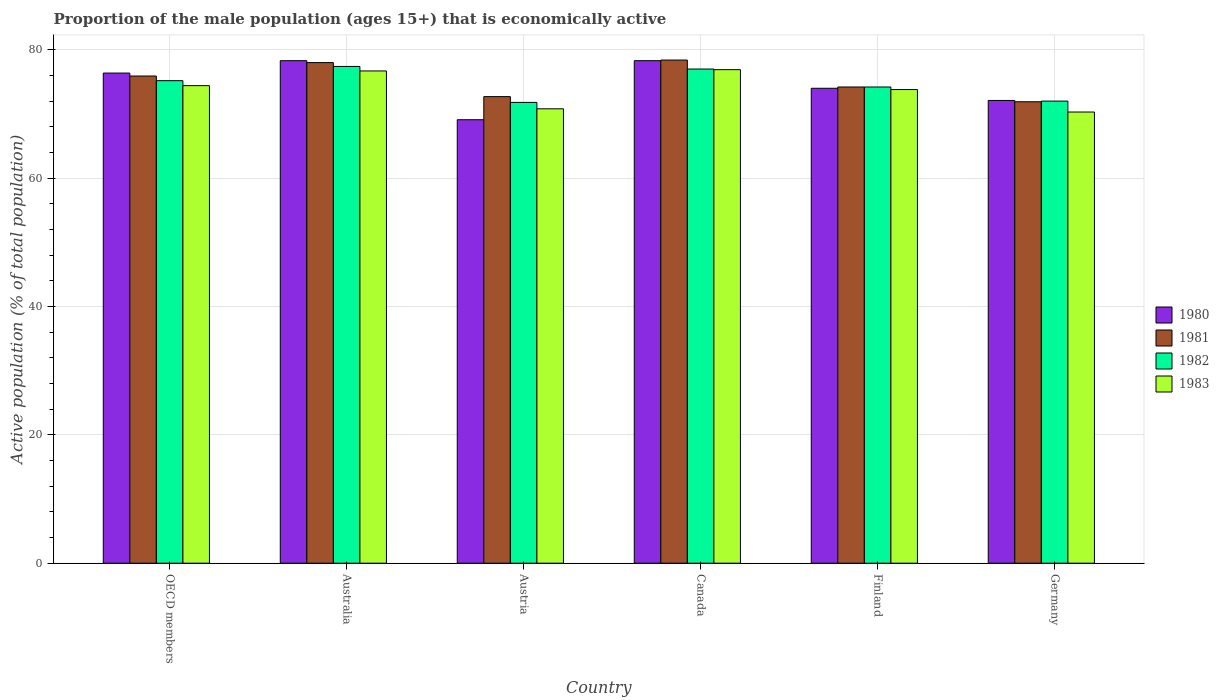How many groups of bars are there?
Ensure brevity in your answer.  6. Are the number of bars per tick equal to the number of legend labels?
Your answer should be very brief. Yes. Are the number of bars on each tick of the X-axis equal?
Your response must be concise. Yes. What is the proportion of the male population that is economically active in 1981 in Canada?
Keep it short and to the point. 78.4. Across all countries, what is the maximum proportion of the male population that is economically active in 1983?
Offer a terse response. 76.9. Across all countries, what is the minimum proportion of the male population that is economically active in 1980?
Your answer should be compact. 69.1. What is the total proportion of the male population that is economically active in 1982 in the graph?
Offer a terse response. 447.58. What is the difference between the proportion of the male population that is economically active in 1982 in Austria and that in Finland?
Offer a very short reply. -2.4. What is the difference between the proportion of the male population that is economically active in 1982 in Canada and the proportion of the male population that is economically active in 1983 in Germany?
Offer a terse response. 6.7. What is the average proportion of the male population that is economically active in 1981 per country?
Your answer should be compact. 75.18. What is the difference between the proportion of the male population that is economically active of/in 1980 and proportion of the male population that is economically active of/in 1982 in Australia?
Provide a short and direct response. 0.9. What is the ratio of the proportion of the male population that is economically active in 1983 in Austria to that in Finland?
Offer a very short reply. 0.96. Is the proportion of the male population that is economically active in 1980 in Austria less than that in OECD members?
Your answer should be very brief. Yes. What is the difference between the highest and the second highest proportion of the male population that is economically active in 1980?
Offer a very short reply. -1.93. What is the difference between the highest and the lowest proportion of the male population that is economically active in 1982?
Your answer should be compact. 5.6. In how many countries, is the proportion of the male population that is economically active in 1980 greater than the average proportion of the male population that is economically active in 1980 taken over all countries?
Offer a very short reply. 3. Is the sum of the proportion of the male population that is economically active in 1982 in Austria and Germany greater than the maximum proportion of the male population that is economically active in 1981 across all countries?
Ensure brevity in your answer.  Yes. Is it the case that in every country, the sum of the proportion of the male population that is economically active in 1981 and proportion of the male population that is economically active in 1982 is greater than the sum of proportion of the male population that is economically active in 1983 and proportion of the male population that is economically active in 1980?
Ensure brevity in your answer.  No. How many countries are there in the graph?
Give a very brief answer. 6. Are the values on the major ticks of Y-axis written in scientific E-notation?
Offer a very short reply. No. How many legend labels are there?
Your answer should be compact. 4. What is the title of the graph?
Ensure brevity in your answer.  Proportion of the male population (ages 15+) that is economically active. Does "2003" appear as one of the legend labels in the graph?
Your answer should be compact. No. What is the label or title of the Y-axis?
Offer a very short reply. Active population (% of total population). What is the Active population (% of total population) in 1980 in OECD members?
Give a very brief answer. 76.37. What is the Active population (% of total population) of 1981 in OECD members?
Keep it short and to the point. 75.91. What is the Active population (% of total population) in 1982 in OECD members?
Your response must be concise. 75.18. What is the Active population (% of total population) of 1983 in OECD members?
Offer a terse response. 74.41. What is the Active population (% of total population) in 1980 in Australia?
Ensure brevity in your answer.  78.3. What is the Active population (% of total population) in 1982 in Australia?
Provide a succinct answer. 77.4. What is the Active population (% of total population) in 1983 in Australia?
Your answer should be very brief. 76.7. What is the Active population (% of total population) in 1980 in Austria?
Make the answer very short. 69.1. What is the Active population (% of total population) in 1981 in Austria?
Make the answer very short. 72.7. What is the Active population (% of total population) in 1982 in Austria?
Ensure brevity in your answer.  71.8. What is the Active population (% of total population) of 1983 in Austria?
Your response must be concise. 70.8. What is the Active population (% of total population) in 1980 in Canada?
Keep it short and to the point. 78.3. What is the Active population (% of total population) in 1981 in Canada?
Provide a succinct answer. 78.4. What is the Active population (% of total population) in 1983 in Canada?
Your answer should be very brief. 76.9. What is the Active population (% of total population) in 1980 in Finland?
Ensure brevity in your answer.  74. What is the Active population (% of total population) in 1981 in Finland?
Your answer should be very brief. 74.2. What is the Active population (% of total population) of 1982 in Finland?
Offer a terse response. 74.2. What is the Active population (% of total population) of 1983 in Finland?
Ensure brevity in your answer.  73.8. What is the Active population (% of total population) in 1980 in Germany?
Keep it short and to the point. 72.1. What is the Active population (% of total population) in 1981 in Germany?
Give a very brief answer. 71.9. What is the Active population (% of total population) in 1983 in Germany?
Keep it short and to the point. 70.3. Across all countries, what is the maximum Active population (% of total population) of 1980?
Ensure brevity in your answer.  78.3. Across all countries, what is the maximum Active population (% of total population) in 1981?
Keep it short and to the point. 78.4. Across all countries, what is the maximum Active population (% of total population) in 1982?
Give a very brief answer. 77.4. Across all countries, what is the maximum Active population (% of total population) in 1983?
Offer a very short reply. 76.9. Across all countries, what is the minimum Active population (% of total population) of 1980?
Provide a succinct answer. 69.1. Across all countries, what is the minimum Active population (% of total population) in 1981?
Ensure brevity in your answer.  71.9. Across all countries, what is the minimum Active population (% of total population) in 1982?
Provide a succinct answer. 71.8. Across all countries, what is the minimum Active population (% of total population) in 1983?
Give a very brief answer. 70.3. What is the total Active population (% of total population) of 1980 in the graph?
Keep it short and to the point. 448.17. What is the total Active population (% of total population) of 1981 in the graph?
Offer a very short reply. 451.11. What is the total Active population (% of total population) of 1982 in the graph?
Ensure brevity in your answer.  447.58. What is the total Active population (% of total population) of 1983 in the graph?
Make the answer very short. 442.91. What is the difference between the Active population (% of total population) of 1980 in OECD members and that in Australia?
Offer a very short reply. -1.93. What is the difference between the Active population (% of total population) of 1981 in OECD members and that in Australia?
Make the answer very short. -2.09. What is the difference between the Active population (% of total population) of 1982 in OECD members and that in Australia?
Provide a short and direct response. -2.22. What is the difference between the Active population (% of total population) of 1983 in OECD members and that in Australia?
Provide a short and direct response. -2.29. What is the difference between the Active population (% of total population) of 1980 in OECD members and that in Austria?
Your answer should be compact. 7.27. What is the difference between the Active population (% of total population) in 1981 in OECD members and that in Austria?
Ensure brevity in your answer.  3.21. What is the difference between the Active population (% of total population) in 1982 in OECD members and that in Austria?
Provide a succinct answer. 3.38. What is the difference between the Active population (% of total population) of 1983 in OECD members and that in Austria?
Provide a succinct answer. 3.61. What is the difference between the Active population (% of total population) in 1980 in OECD members and that in Canada?
Give a very brief answer. -1.93. What is the difference between the Active population (% of total population) of 1981 in OECD members and that in Canada?
Your response must be concise. -2.49. What is the difference between the Active population (% of total population) of 1982 in OECD members and that in Canada?
Your response must be concise. -1.82. What is the difference between the Active population (% of total population) in 1983 in OECD members and that in Canada?
Your answer should be very brief. -2.49. What is the difference between the Active population (% of total population) of 1980 in OECD members and that in Finland?
Provide a short and direct response. 2.37. What is the difference between the Active population (% of total population) of 1981 in OECD members and that in Finland?
Your answer should be compact. 1.71. What is the difference between the Active population (% of total population) of 1982 in OECD members and that in Finland?
Give a very brief answer. 0.98. What is the difference between the Active population (% of total population) of 1983 in OECD members and that in Finland?
Your answer should be compact. 0.61. What is the difference between the Active population (% of total population) in 1980 in OECD members and that in Germany?
Offer a very short reply. 4.27. What is the difference between the Active population (% of total population) in 1981 in OECD members and that in Germany?
Offer a very short reply. 4.01. What is the difference between the Active population (% of total population) of 1982 in OECD members and that in Germany?
Make the answer very short. 3.18. What is the difference between the Active population (% of total population) in 1983 in OECD members and that in Germany?
Your response must be concise. 4.11. What is the difference between the Active population (% of total population) in 1981 in Australia and that in Austria?
Provide a short and direct response. 5.3. What is the difference between the Active population (% of total population) of 1981 in Australia and that in Canada?
Your answer should be compact. -0.4. What is the difference between the Active population (% of total population) in 1982 in Australia and that in Canada?
Provide a short and direct response. 0.4. What is the difference between the Active population (% of total population) of 1980 in Australia and that in Finland?
Your answer should be compact. 4.3. What is the difference between the Active population (% of total population) in 1983 in Australia and that in Finland?
Your answer should be compact. 2.9. What is the difference between the Active population (% of total population) in 1981 in Australia and that in Germany?
Provide a short and direct response. 6.1. What is the difference between the Active population (% of total population) in 1983 in Australia and that in Germany?
Offer a terse response. 6.4. What is the difference between the Active population (% of total population) in 1980 in Austria and that in Canada?
Your answer should be very brief. -9.2. What is the difference between the Active population (% of total population) in 1983 in Austria and that in Canada?
Give a very brief answer. -6.1. What is the difference between the Active population (% of total population) in 1980 in Austria and that in Finland?
Your response must be concise. -4.9. What is the difference between the Active population (% of total population) in 1981 in Austria and that in Germany?
Keep it short and to the point. 0.8. What is the difference between the Active population (% of total population) in 1983 in Austria and that in Germany?
Make the answer very short. 0.5. What is the difference between the Active population (% of total population) of 1980 in Canada and that in Finland?
Offer a terse response. 4.3. What is the difference between the Active population (% of total population) of 1982 in Canada and that in Finland?
Offer a very short reply. 2.8. What is the difference between the Active population (% of total population) of 1981 in Canada and that in Germany?
Offer a very short reply. 6.5. What is the difference between the Active population (% of total population) of 1982 in Canada and that in Germany?
Offer a terse response. 5. What is the difference between the Active population (% of total population) of 1980 in Finland and that in Germany?
Give a very brief answer. 1.9. What is the difference between the Active population (% of total population) in 1981 in Finland and that in Germany?
Ensure brevity in your answer.  2.3. What is the difference between the Active population (% of total population) of 1982 in Finland and that in Germany?
Ensure brevity in your answer.  2.2. What is the difference between the Active population (% of total population) of 1983 in Finland and that in Germany?
Give a very brief answer. 3.5. What is the difference between the Active population (% of total population) in 1980 in OECD members and the Active population (% of total population) in 1981 in Australia?
Offer a terse response. -1.63. What is the difference between the Active population (% of total population) in 1980 in OECD members and the Active population (% of total population) in 1982 in Australia?
Give a very brief answer. -1.03. What is the difference between the Active population (% of total population) of 1980 in OECD members and the Active population (% of total population) of 1983 in Australia?
Your answer should be very brief. -0.33. What is the difference between the Active population (% of total population) in 1981 in OECD members and the Active population (% of total population) in 1982 in Australia?
Provide a succinct answer. -1.49. What is the difference between the Active population (% of total population) of 1981 in OECD members and the Active population (% of total population) of 1983 in Australia?
Ensure brevity in your answer.  -0.79. What is the difference between the Active population (% of total population) of 1982 in OECD members and the Active population (% of total population) of 1983 in Australia?
Offer a terse response. -1.52. What is the difference between the Active population (% of total population) of 1980 in OECD members and the Active population (% of total population) of 1981 in Austria?
Offer a very short reply. 3.67. What is the difference between the Active population (% of total population) of 1980 in OECD members and the Active population (% of total population) of 1982 in Austria?
Give a very brief answer. 4.57. What is the difference between the Active population (% of total population) of 1980 in OECD members and the Active population (% of total population) of 1983 in Austria?
Offer a terse response. 5.57. What is the difference between the Active population (% of total population) in 1981 in OECD members and the Active population (% of total population) in 1982 in Austria?
Your answer should be very brief. 4.11. What is the difference between the Active population (% of total population) in 1981 in OECD members and the Active population (% of total population) in 1983 in Austria?
Offer a very short reply. 5.11. What is the difference between the Active population (% of total population) of 1982 in OECD members and the Active population (% of total population) of 1983 in Austria?
Ensure brevity in your answer.  4.38. What is the difference between the Active population (% of total population) in 1980 in OECD members and the Active population (% of total population) in 1981 in Canada?
Make the answer very short. -2.03. What is the difference between the Active population (% of total population) of 1980 in OECD members and the Active population (% of total population) of 1982 in Canada?
Ensure brevity in your answer.  -0.63. What is the difference between the Active population (% of total population) of 1980 in OECD members and the Active population (% of total population) of 1983 in Canada?
Keep it short and to the point. -0.53. What is the difference between the Active population (% of total population) in 1981 in OECD members and the Active population (% of total population) in 1982 in Canada?
Make the answer very short. -1.09. What is the difference between the Active population (% of total population) in 1981 in OECD members and the Active population (% of total population) in 1983 in Canada?
Ensure brevity in your answer.  -0.99. What is the difference between the Active population (% of total population) in 1982 in OECD members and the Active population (% of total population) in 1983 in Canada?
Offer a very short reply. -1.72. What is the difference between the Active population (% of total population) in 1980 in OECD members and the Active population (% of total population) in 1981 in Finland?
Your answer should be compact. 2.17. What is the difference between the Active population (% of total population) of 1980 in OECD members and the Active population (% of total population) of 1982 in Finland?
Provide a short and direct response. 2.17. What is the difference between the Active population (% of total population) of 1980 in OECD members and the Active population (% of total population) of 1983 in Finland?
Offer a very short reply. 2.57. What is the difference between the Active population (% of total population) in 1981 in OECD members and the Active population (% of total population) in 1982 in Finland?
Your response must be concise. 1.71. What is the difference between the Active population (% of total population) in 1981 in OECD members and the Active population (% of total population) in 1983 in Finland?
Your answer should be very brief. 2.11. What is the difference between the Active population (% of total population) of 1982 in OECD members and the Active population (% of total population) of 1983 in Finland?
Provide a short and direct response. 1.38. What is the difference between the Active population (% of total population) in 1980 in OECD members and the Active population (% of total population) in 1981 in Germany?
Make the answer very short. 4.47. What is the difference between the Active population (% of total population) in 1980 in OECD members and the Active population (% of total population) in 1982 in Germany?
Your answer should be compact. 4.37. What is the difference between the Active population (% of total population) in 1980 in OECD members and the Active population (% of total population) in 1983 in Germany?
Make the answer very short. 6.07. What is the difference between the Active population (% of total population) in 1981 in OECD members and the Active population (% of total population) in 1982 in Germany?
Offer a very short reply. 3.91. What is the difference between the Active population (% of total population) of 1981 in OECD members and the Active population (% of total population) of 1983 in Germany?
Keep it short and to the point. 5.61. What is the difference between the Active population (% of total population) of 1982 in OECD members and the Active population (% of total population) of 1983 in Germany?
Your answer should be compact. 4.88. What is the difference between the Active population (% of total population) of 1981 in Australia and the Active population (% of total population) of 1982 in Austria?
Your answer should be compact. 6.2. What is the difference between the Active population (% of total population) in 1981 in Australia and the Active population (% of total population) in 1983 in Austria?
Offer a terse response. 7.2. What is the difference between the Active population (% of total population) in 1982 in Australia and the Active population (% of total population) in 1983 in Austria?
Your answer should be compact. 6.6. What is the difference between the Active population (% of total population) of 1980 in Australia and the Active population (% of total population) of 1982 in Canada?
Provide a short and direct response. 1.3. What is the difference between the Active population (% of total population) of 1981 in Australia and the Active population (% of total population) of 1982 in Canada?
Make the answer very short. 1. What is the difference between the Active population (% of total population) of 1981 in Australia and the Active population (% of total population) of 1982 in Finland?
Make the answer very short. 3.8. What is the difference between the Active population (% of total population) of 1982 in Australia and the Active population (% of total population) of 1983 in Finland?
Your response must be concise. 3.6. What is the difference between the Active population (% of total population) of 1980 in Australia and the Active population (% of total population) of 1981 in Germany?
Ensure brevity in your answer.  6.4. What is the difference between the Active population (% of total population) in 1980 in Australia and the Active population (% of total population) in 1982 in Germany?
Ensure brevity in your answer.  6.3. What is the difference between the Active population (% of total population) in 1981 in Australia and the Active population (% of total population) in 1983 in Germany?
Your answer should be compact. 7.7. What is the difference between the Active population (% of total population) of 1982 in Australia and the Active population (% of total population) of 1983 in Germany?
Offer a very short reply. 7.1. What is the difference between the Active population (% of total population) in 1980 in Austria and the Active population (% of total population) in 1982 in Canada?
Offer a very short reply. -7.9. What is the difference between the Active population (% of total population) of 1980 in Austria and the Active population (% of total population) of 1983 in Canada?
Make the answer very short. -7.8. What is the difference between the Active population (% of total population) in 1981 in Austria and the Active population (% of total population) in 1982 in Canada?
Offer a terse response. -4.3. What is the difference between the Active population (% of total population) in 1981 in Austria and the Active population (% of total population) in 1983 in Canada?
Make the answer very short. -4.2. What is the difference between the Active population (% of total population) in 1980 in Austria and the Active population (% of total population) in 1982 in Finland?
Your answer should be compact. -5.1. What is the difference between the Active population (% of total population) in 1980 in Austria and the Active population (% of total population) in 1983 in Finland?
Keep it short and to the point. -4.7. What is the difference between the Active population (% of total population) in 1981 in Austria and the Active population (% of total population) in 1982 in Finland?
Provide a succinct answer. -1.5. What is the difference between the Active population (% of total population) of 1981 in Austria and the Active population (% of total population) of 1983 in Finland?
Your answer should be compact. -1.1. What is the difference between the Active population (% of total population) of 1981 in Austria and the Active population (% of total population) of 1982 in Germany?
Offer a terse response. 0.7. What is the difference between the Active population (% of total population) of 1982 in Austria and the Active population (% of total population) of 1983 in Germany?
Keep it short and to the point. 1.5. What is the difference between the Active population (% of total population) in 1981 in Canada and the Active population (% of total population) in 1982 in Finland?
Provide a short and direct response. 4.2. What is the difference between the Active population (% of total population) in 1981 in Canada and the Active population (% of total population) in 1983 in Finland?
Provide a succinct answer. 4.6. What is the difference between the Active population (% of total population) of 1982 in Canada and the Active population (% of total population) of 1983 in Finland?
Give a very brief answer. 3.2. What is the difference between the Active population (% of total population) of 1980 in Canada and the Active population (% of total population) of 1982 in Germany?
Offer a very short reply. 6.3. What is the difference between the Active population (% of total population) in 1980 in Canada and the Active population (% of total population) in 1983 in Germany?
Your answer should be compact. 8. What is the difference between the Active population (% of total population) in 1981 in Canada and the Active population (% of total population) in 1982 in Germany?
Give a very brief answer. 6.4. What is the difference between the Active population (% of total population) of 1981 in Canada and the Active population (% of total population) of 1983 in Germany?
Offer a very short reply. 8.1. What is the difference between the Active population (% of total population) in 1980 in Finland and the Active population (% of total population) in 1981 in Germany?
Give a very brief answer. 2.1. What is the difference between the Active population (% of total population) in 1981 in Finland and the Active population (% of total population) in 1983 in Germany?
Ensure brevity in your answer.  3.9. What is the average Active population (% of total population) in 1980 per country?
Ensure brevity in your answer.  74.7. What is the average Active population (% of total population) in 1981 per country?
Offer a very short reply. 75.18. What is the average Active population (% of total population) of 1982 per country?
Keep it short and to the point. 74.6. What is the average Active population (% of total population) in 1983 per country?
Your answer should be very brief. 73.82. What is the difference between the Active population (% of total population) of 1980 and Active population (% of total population) of 1981 in OECD members?
Offer a very short reply. 0.46. What is the difference between the Active population (% of total population) of 1980 and Active population (% of total population) of 1982 in OECD members?
Provide a succinct answer. 1.19. What is the difference between the Active population (% of total population) of 1980 and Active population (% of total population) of 1983 in OECD members?
Your response must be concise. 1.96. What is the difference between the Active population (% of total population) of 1981 and Active population (% of total population) of 1982 in OECD members?
Provide a succinct answer. 0.73. What is the difference between the Active population (% of total population) of 1981 and Active population (% of total population) of 1983 in OECD members?
Your response must be concise. 1.5. What is the difference between the Active population (% of total population) of 1982 and Active population (% of total population) of 1983 in OECD members?
Your answer should be compact. 0.77. What is the difference between the Active population (% of total population) in 1980 and Active population (% of total population) in 1982 in Australia?
Your answer should be very brief. 0.9. What is the difference between the Active population (% of total population) of 1980 and Active population (% of total population) of 1981 in Austria?
Offer a terse response. -3.6. What is the difference between the Active population (% of total population) of 1981 and Active population (% of total population) of 1982 in Austria?
Your response must be concise. 0.9. What is the difference between the Active population (% of total population) in 1982 and Active population (% of total population) in 1983 in Austria?
Offer a terse response. 1. What is the difference between the Active population (% of total population) of 1980 and Active population (% of total population) of 1983 in Canada?
Offer a very short reply. 1.4. What is the difference between the Active population (% of total population) of 1981 and Active population (% of total population) of 1982 in Canada?
Ensure brevity in your answer.  1.4. What is the difference between the Active population (% of total population) of 1981 and Active population (% of total population) of 1983 in Canada?
Provide a short and direct response. 1.5. What is the difference between the Active population (% of total population) of 1982 and Active population (% of total population) of 1983 in Canada?
Ensure brevity in your answer.  0.1. What is the difference between the Active population (% of total population) in 1980 and Active population (% of total population) in 1981 in Finland?
Keep it short and to the point. -0.2. What is the difference between the Active population (% of total population) of 1980 and Active population (% of total population) of 1982 in Finland?
Your answer should be compact. -0.2. What is the difference between the Active population (% of total population) of 1981 and Active population (% of total population) of 1982 in Finland?
Offer a terse response. 0. What is the difference between the Active population (% of total population) in 1980 and Active population (% of total population) in 1981 in Germany?
Provide a succinct answer. 0.2. What is the difference between the Active population (% of total population) of 1980 and Active population (% of total population) of 1983 in Germany?
Make the answer very short. 1.8. What is the difference between the Active population (% of total population) of 1981 and Active population (% of total population) of 1982 in Germany?
Make the answer very short. -0.1. What is the difference between the Active population (% of total population) of 1981 and Active population (% of total population) of 1983 in Germany?
Make the answer very short. 1.6. What is the difference between the Active population (% of total population) of 1982 and Active population (% of total population) of 1983 in Germany?
Offer a terse response. 1.7. What is the ratio of the Active population (% of total population) in 1980 in OECD members to that in Australia?
Provide a short and direct response. 0.98. What is the ratio of the Active population (% of total population) of 1981 in OECD members to that in Australia?
Offer a very short reply. 0.97. What is the ratio of the Active population (% of total population) in 1982 in OECD members to that in Australia?
Provide a succinct answer. 0.97. What is the ratio of the Active population (% of total population) in 1983 in OECD members to that in Australia?
Provide a succinct answer. 0.97. What is the ratio of the Active population (% of total population) in 1980 in OECD members to that in Austria?
Your answer should be very brief. 1.11. What is the ratio of the Active population (% of total population) in 1981 in OECD members to that in Austria?
Provide a succinct answer. 1.04. What is the ratio of the Active population (% of total population) in 1982 in OECD members to that in Austria?
Provide a succinct answer. 1.05. What is the ratio of the Active population (% of total population) in 1983 in OECD members to that in Austria?
Make the answer very short. 1.05. What is the ratio of the Active population (% of total population) of 1980 in OECD members to that in Canada?
Provide a succinct answer. 0.98. What is the ratio of the Active population (% of total population) in 1981 in OECD members to that in Canada?
Ensure brevity in your answer.  0.97. What is the ratio of the Active population (% of total population) of 1982 in OECD members to that in Canada?
Give a very brief answer. 0.98. What is the ratio of the Active population (% of total population) of 1983 in OECD members to that in Canada?
Give a very brief answer. 0.97. What is the ratio of the Active population (% of total population) in 1980 in OECD members to that in Finland?
Give a very brief answer. 1.03. What is the ratio of the Active population (% of total population) of 1982 in OECD members to that in Finland?
Your answer should be very brief. 1.01. What is the ratio of the Active population (% of total population) in 1983 in OECD members to that in Finland?
Your response must be concise. 1.01. What is the ratio of the Active population (% of total population) of 1980 in OECD members to that in Germany?
Your answer should be very brief. 1.06. What is the ratio of the Active population (% of total population) of 1981 in OECD members to that in Germany?
Make the answer very short. 1.06. What is the ratio of the Active population (% of total population) of 1982 in OECD members to that in Germany?
Ensure brevity in your answer.  1.04. What is the ratio of the Active population (% of total population) in 1983 in OECD members to that in Germany?
Offer a terse response. 1.06. What is the ratio of the Active population (% of total population) in 1980 in Australia to that in Austria?
Keep it short and to the point. 1.13. What is the ratio of the Active population (% of total population) in 1981 in Australia to that in Austria?
Ensure brevity in your answer.  1.07. What is the ratio of the Active population (% of total population) in 1982 in Australia to that in Austria?
Ensure brevity in your answer.  1.08. What is the ratio of the Active population (% of total population) of 1983 in Australia to that in Austria?
Keep it short and to the point. 1.08. What is the ratio of the Active population (% of total population) in 1981 in Australia to that in Canada?
Keep it short and to the point. 0.99. What is the ratio of the Active population (% of total population) in 1982 in Australia to that in Canada?
Ensure brevity in your answer.  1.01. What is the ratio of the Active population (% of total population) in 1983 in Australia to that in Canada?
Your answer should be compact. 1. What is the ratio of the Active population (% of total population) of 1980 in Australia to that in Finland?
Your answer should be compact. 1.06. What is the ratio of the Active population (% of total population) of 1981 in Australia to that in Finland?
Give a very brief answer. 1.05. What is the ratio of the Active population (% of total population) in 1982 in Australia to that in Finland?
Your answer should be very brief. 1.04. What is the ratio of the Active population (% of total population) in 1983 in Australia to that in Finland?
Provide a succinct answer. 1.04. What is the ratio of the Active population (% of total population) of 1980 in Australia to that in Germany?
Your answer should be very brief. 1.09. What is the ratio of the Active population (% of total population) in 1981 in Australia to that in Germany?
Keep it short and to the point. 1.08. What is the ratio of the Active population (% of total population) in 1982 in Australia to that in Germany?
Ensure brevity in your answer.  1.07. What is the ratio of the Active population (% of total population) of 1983 in Australia to that in Germany?
Ensure brevity in your answer.  1.09. What is the ratio of the Active population (% of total population) in 1980 in Austria to that in Canada?
Offer a very short reply. 0.88. What is the ratio of the Active population (% of total population) in 1981 in Austria to that in Canada?
Keep it short and to the point. 0.93. What is the ratio of the Active population (% of total population) in 1982 in Austria to that in Canada?
Give a very brief answer. 0.93. What is the ratio of the Active population (% of total population) in 1983 in Austria to that in Canada?
Make the answer very short. 0.92. What is the ratio of the Active population (% of total population) of 1980 in Austria to that in Finland?
Provide a succinct answer. 0.93. What is the ratio of the Active population (% of total population) in 1981 in Austria to that in Finland?
Give a very brief answer. 0.98. What is the ratio of the Active population (% of total population) of 1982 in Austria to that in Finland?
Provide a succinct answer. 0.97. What is the ratio of the Active population (% of total population) in 1983 in Austria to that in Finland?
Your answer should be compact. 0.96. What is the ratio of the Active population (% of total population) of 1980 in Austria to that in Germany?
Your answer should be very brief. 0.96. What is the ratio of the Active population (% of total population) in 1981 in Austria to that in Germany?
Make the answer very short. 1.01. What is the ratio of the Active population (% of total population) of 1983 in Austria to that in Germany?
Your response must be concise. 1.01. What is the ratio of the Active population (% of total population) of 1980 in Canada to that in Finland?
Provide a succinct answer. 1.06. What is the ratio of the Active population (% of total population) in 1981 in Canada to that in Finland?
Make the answer very short. 1.06. What is the ratio of the Active population (% of total population) in 1982 in Canada to that in Finland?
Offer a terse response. 1.04. What is the ratio of the Active population (% of total population) of 1983 in Canada to that in Finland?
Ensure brevity in your answer.  1.04. What is the ratio of the Active population (% of total population) of 1980 in Canada to that in Germany?
Provide a short and direct response. 1.09. What is the ratio of the Active population (% of total population) in 1981 in Canada to that in Germany?
Keep it short and to the point. 1.09. What is the ratio of the Active population (% of total population) of 1982 in Canada to that in Germany?
Offer a very short reply. 1.07. What is the ratio of the Active population (% of total population) in 1983 in Canada to that in Germany?
Ensure brevity in your answer.  1.09. What is the ratio of the Active population (% of total population) in 1980 in Finland to that in Germany?
Offer a very short reply. 1.03. What is the ratio of the Active population (% of total population) in 1981 in Finland to that in Germany?
Ensure brevity in your answer.  1.03. What is the ratio of the Active population (% of total population) of 1982 in Finland to that in Germany?
Your answer should be compact. 1.03. What is the ratio of the Active population (% of total population) in 1983 in Finland to that in Germany?
Offer a very short reply. 1.05. What is the difference between the highest and the second highest Active population (% of total population) in 1981?
Your response must be concise. 0.4. What is the difference between the highest and the lowest Active population (% of total population) of 1980?
Provide a succinct answer. 9.2. What is the difference between the highest and the lowest Active population (% of total population) of 1981?
Make the answer very short. 6.5. What is the difference between the highest and the lowest Active population (% of total population) of 1982?
Provide a short and direct response. 5.6. 